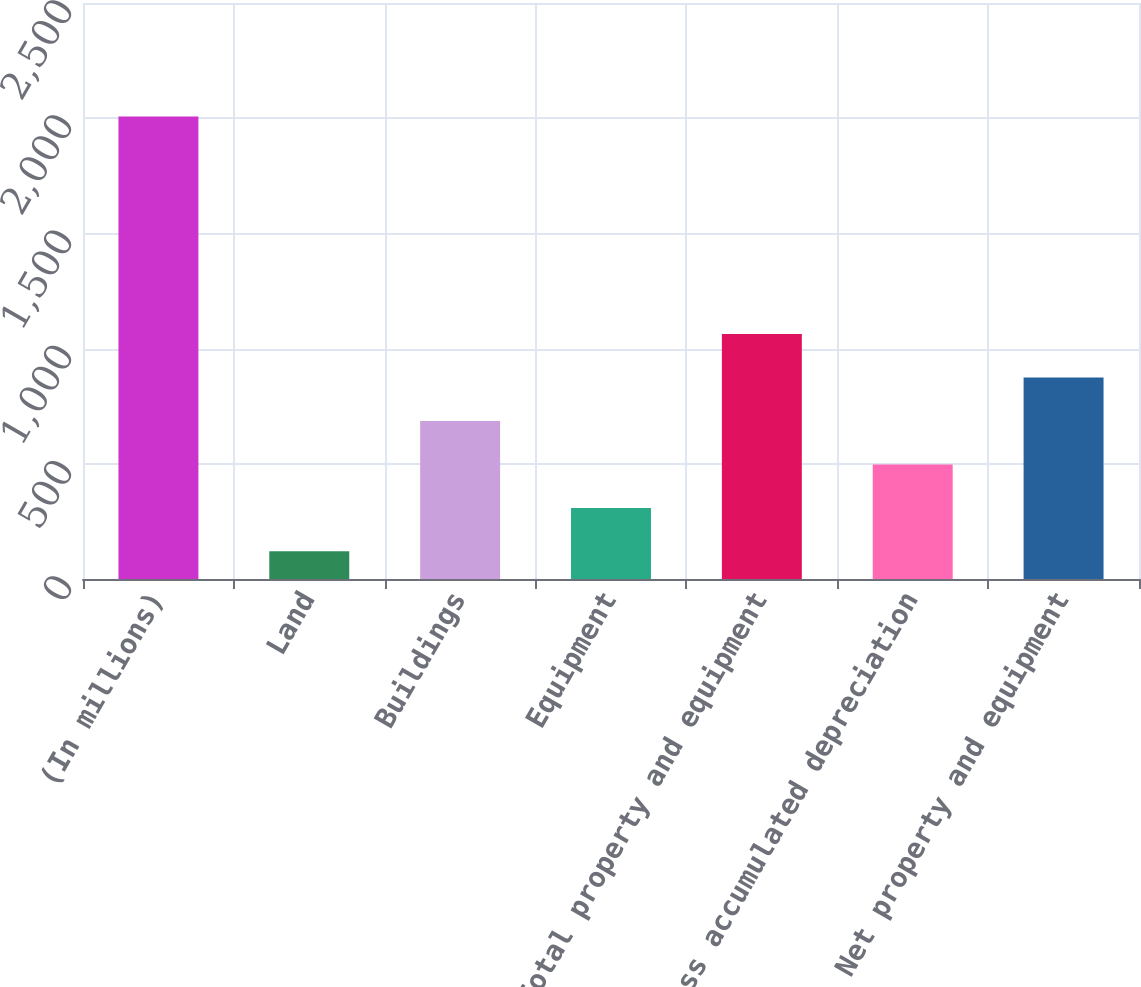Convert chart to OTSL. <chart><loc_0><loc_0><loc_500><loc_500><bar_chart><fcel>(In millions)<fcel>Land<fcel>Buildings<fcel>Equipment<fcel>Total property and equipment<fcel>Less accumulated depreciation<fcel>Net property and equipment<nl><fcel>2007<fcel>120<fcel>686.1<fcel>308.7<fcel>1063.5<fcel>497.4<fcel>874.8<nl></chart> 